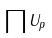Convert formula to latex. <formula><loc_0><loc_0><loc_500><loc_500>\prod U _ { p }</formula> 